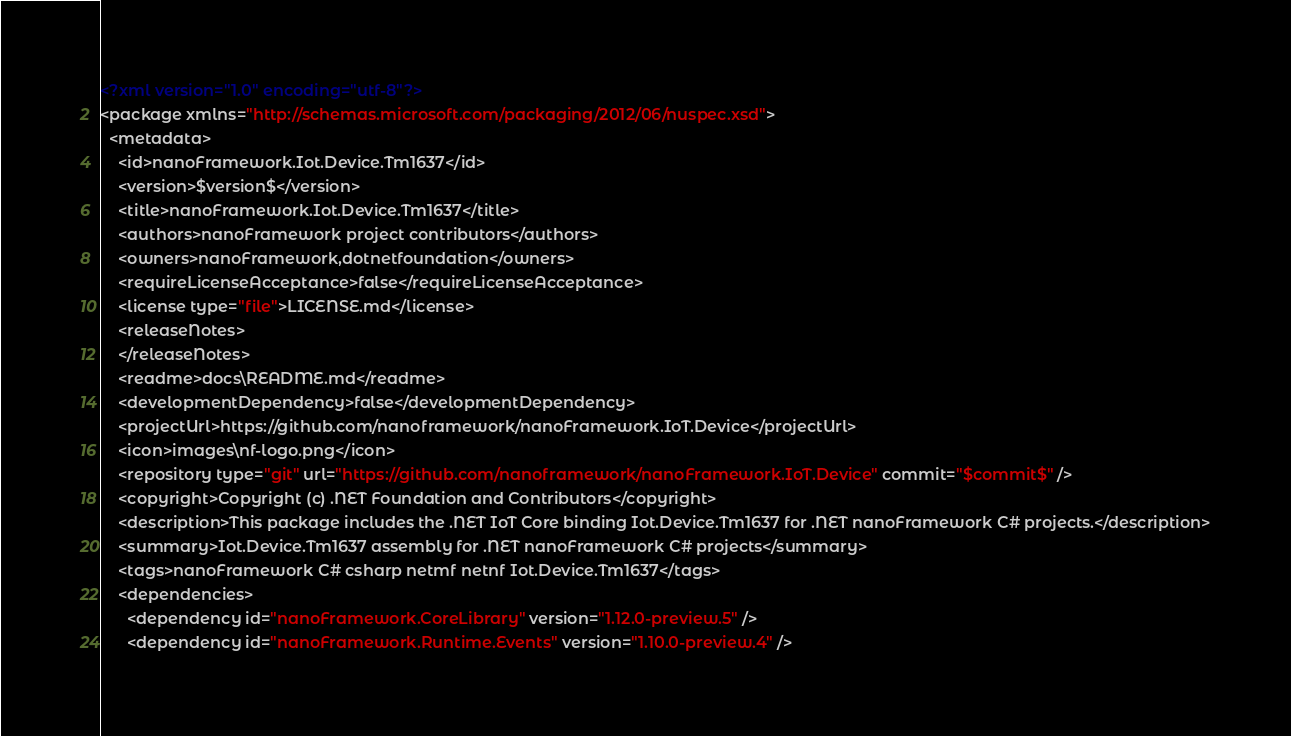<code> <loc_0><loc_0><loc_500><loc_500><_XML_><?xml version="1.0" encoding="utf-8"?>
<package xmlns="http://schemas.microsoft.com/packaging/2012/06/nuspec.xsd">
  <metadata>
    <id>nanoFramework.Iot.Device.Tm1637</id>
    <version>$version$</version>
    <title>nanoFramework.Iot.Device.Tm1637</title>
    <authors>nanoFramework project contributors</authors>
    <owners>nanoFramework,dotnetfoundation</owners>
    <requireLicenseAcceptance>false</requireLicenseAcceptance>
    <license type="file">LICENSE.md</license>
    <releaseNotes>
    </releaseNotes>
    <readme>docs\README.md</readme>
    <developmentDependency>false</developmentDependency>
    <projectUrl>https://github.com/nanoframework/nanoFramework.IoT.Device</projectUrl>
    <icon>images\nf-logo.png</icon>
    <repository type="git" url="https://github.com/nanoframework/nanoFramework.IoT.Device" commit="$commit$" />
    <copyright>Copyright (c) .NET Foundation and Contributors</copyright>
    <description>This package includes the .NET IoT Core binding Iot.Device.Tm1637 for .NET nanoFramework C# projects.</description>
    <summary>Iot.Device.Tm1637 assembly for .NET nanoFramework C# projects</summary>
    <tags>nanoFramework C# csharp netmf netnf Iot.Device.Tm1637</tags>
    <dependencies>
      <dependency id="nanoFramework.CoreLibrary" version="1.12.0-preview.5" />
      <dependency id="nanoFramework.Runtime.Events" version="1.10.0-preview.4" /></code> 